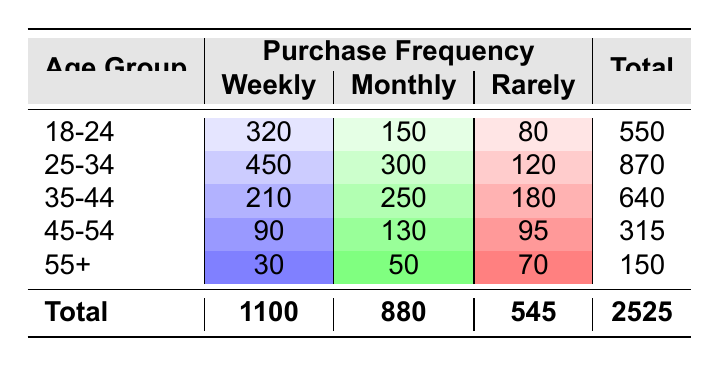What is the total number of online shoppers in the age group 25-34? To find the total number of online shoppers in the age group 25-34, we refer to the "Total" column for this age group, which is listed as 870.
Answer: 870 Which age group has the highest purchase frequency for "Weekly"? Looking at the "Weekly" column, the age group 25-34 has the highest count with 450.
Answer: 25-34 How many online shoppers in the age group 55+ purchase "Rarely"? For the age group 55+, the "Rarely" category shows a count of 70 shoppers.
Answer: 70 What is the average number of shoppers across all age groups for "Monthly" purchases? To find the average for "Monthly", we sum the counts: 150 + 300 + 250 + 130 + 50 = 880. Then we divide by the number of age groups (5): 880 / 5 = 176.
Answer: 176 Is it true that the total number of shoppers who shop "Weekly" is greater than those who shop "Rarely"? The total for "Weekly" is 1100 and for "Rarely," it is 545. Since 1100 is greater than 545, the statement is true.
Answer: Yes Which age group shows the least number of shoppers for "Weekly" purchases? Referring to the "Weekly" column, the age group 55+ has the least count with 30 shoppers.
Answer: 55+ What is the difference in the number of "Monthly" shoppers between age groups 25-34 and 35-44? The count for "Monthly" shoppers in age group 25-34 is 300 and in 35-44 is 250. The difference is 300 - 250 = 50.
Answer: 50 What percentage of the total shoppers is represented by those in the age group 45-54 who purchase "Monthly"? The count for age group 45-54 who purchase "Monthly" is 130. The total number of shoppers is 2525. To find the percentage: (130 / 2525) * 100 ≈ 5.15%.
Answer: 5.15% Which purchase frequency category has the lowest total count across all age groups? Summing up the counts for "Rarely" gives 80 + 120 + 180 + 95 + 70 = 545. For "Monthly," it's 150 + 300 + 250 + 130 + 50 = 880. "Weekly" totals to 1100, making "Rarely" the lowest count category.
Answer: Rarely 